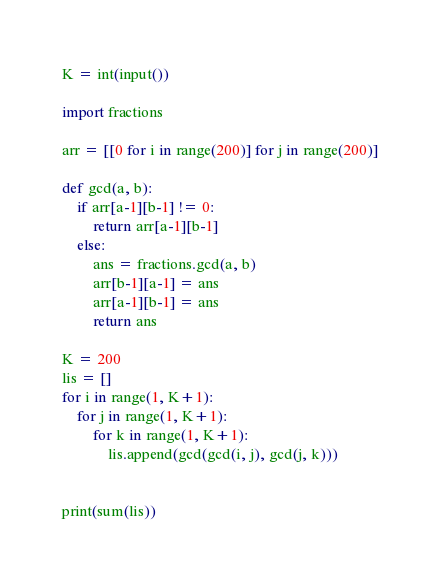<code> <loc_0><loc_0><loc_500><loc_500><_Python_>K = int(input())

import fractions

arr = [[0 for i in range(200)] for j in range(200)]

def gcd(a, b):
    if arr[a-1][b-1] != 0:
        return arr[a-1][b-1]
    else:
        ans = fractions.gcd(a, b)
        arr[b-1][a-1] = ans
        arr[a-1][b-1] = ans
        return ans

K = 200
lis = []
for i in range(1, K+1):
    for j in range(1, K+1):
        for k in range(1, K+1):
            lis.append(gcd(gcd(i, j), gcd(j, k)))


print(sum(lis))</code> 